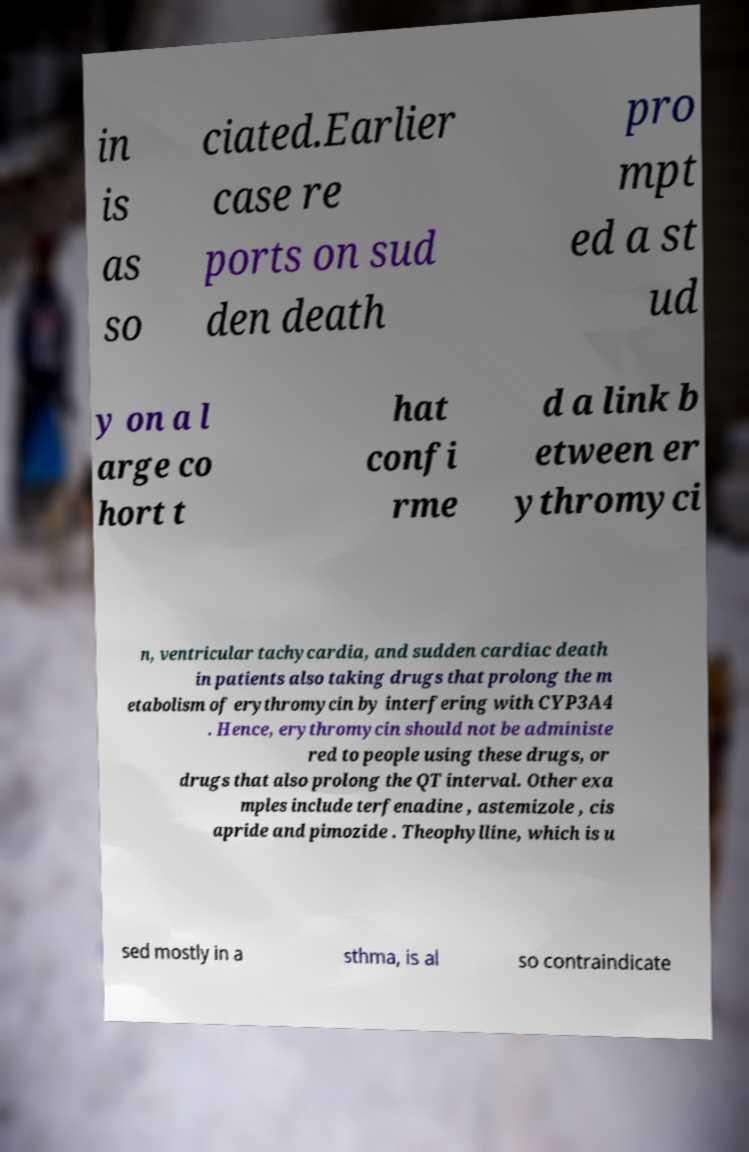Can you read and provide the text displayed in the image?This photo seems to have some interesting text. Can you extract and type it out for me? in is as so ciated.Earlier case re ports on sud den death pro mpt ed a st ud y on a l arge co hort t hat confi rme d a link b etween er ythromyci n, ventricular tachycardia, and sudden cardiac death in patients also taking drugs that prolong the m etabolism of erythromycin by interfering with CYP3A4 . Hence, erythromycin should not be administe red to people using these drugs, or drugs that also prolong the QT interval. Other exa mples include terfenadine , astemizole , cis apride and pimozide . Theophylline, which is u sed mostly in a sthma, is al so contraindicate 